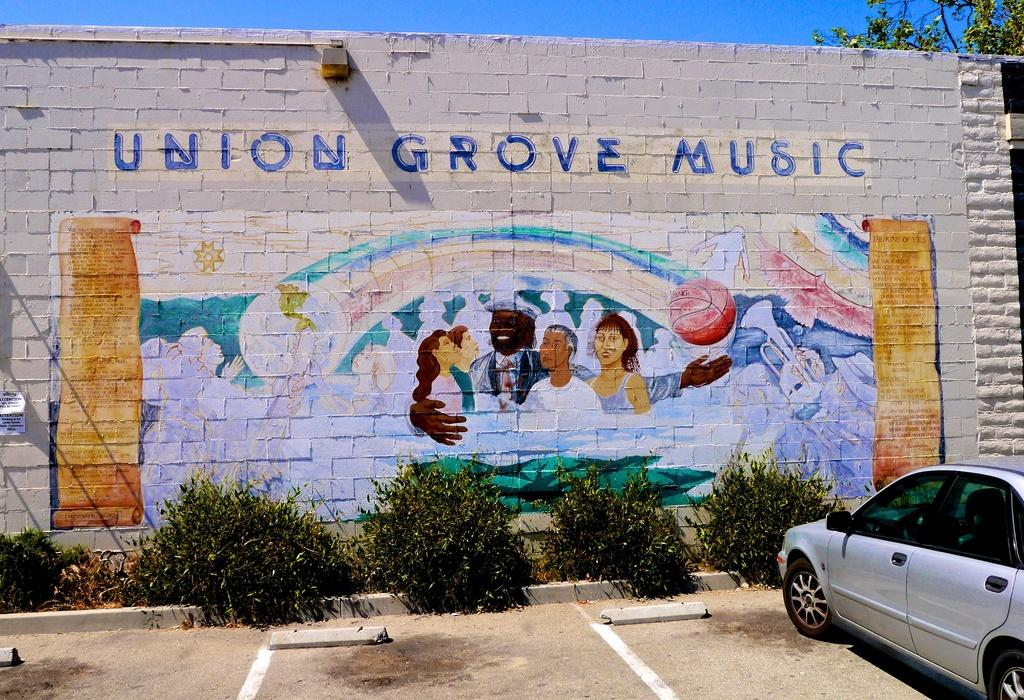What is hanging on the wall in the image? There is a painting on the wall in the image. What type of living organisms can be seen in the image? Plants and trees are visible in the image. What is the vehicle in the image? There is a vehicle in the image, but the specific type is not mentioned. What is written on the wall in the image? There is text written on the wall in the image. What is visible in the background of the image? The sky is visible in the background of the image. Where is the nest located in the image? There is no nest present in the image. What type of respect is shown towards the painting in the image? The image does not convey any specific type of respect towards the painting; it simply shows the painting hanging on the wall. 